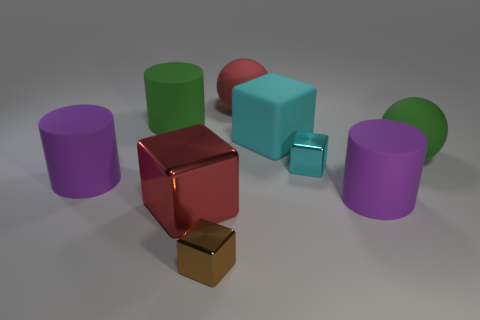Is the number of green rubber objects that are in front of the large matte block greater than the number of balls that are in front of the big green rubber ball?
Your response must be concise. Yes. What shape is the small cyan shiny object?
Ensure brevity in your answer.  Cube. Do the big purple cylinder that is on the right side of the large red metal thing and the big purple thing left of the large red metallic object have the same material?
Make the answer very short. Yes. There is a tiny metal object that is behind the big metal block; what is its shape?
Provide a succinct answer. Cube. There is another matte object that is the same shape as the large red matte thing; what is its size?
Your answer should be compact. Large. Does the rubber block have the same color as the big metallic thing?
Give a very brief answer. No. Is there anything else that is the same shape as the large cyan rubber thing?
Give a very brief answer. Yes. There is a cylinder that is to the right of the small brown metal block; are there any red objects behind it?
Ensure brevity in your answer.  Yes. What is the color of the other big metal thing that is the same shape as the brown object?
Your answer should be very brief. Red. How many other large objects have the same color as the large metal thing?
Provide a succinct answer. 1. 